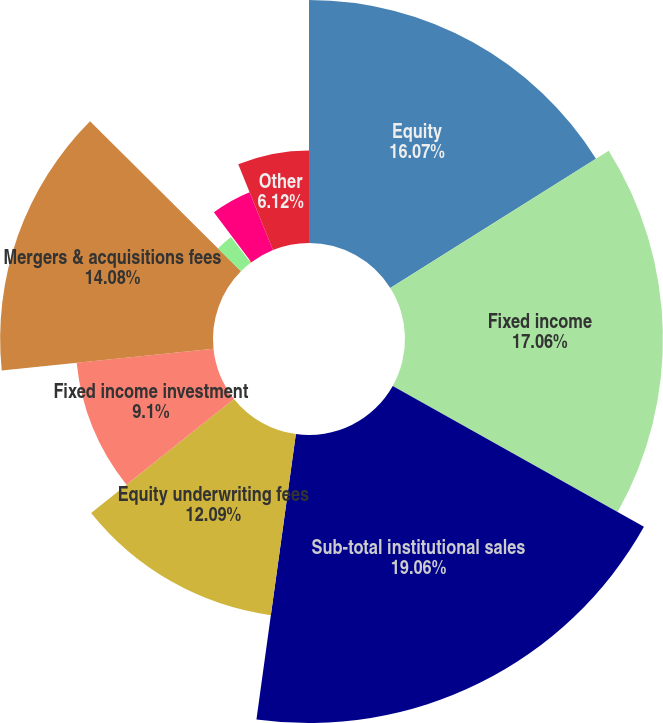Convert chart. <chart><loc_0><loc_0><loc_500><loc_500><pie_chart><fcel>Equity<fcel>Fixed income<fcel>Sub-total institutional sales<fcel>Equity underwriting fees<fcel>Fixed income investment<fcel>Mergers & acquisitions fees<fcel>Tax credit funds syndication<fcel>Private placement fees<fcel>Trading profit<fcel>Other<nl><fcel>16.07%<fcel>17.06%<fcel>19.05%<fcel>12.09%<fcel>9.1%<fcel>14.08%<fcel>2.14%<fcel>0.15%<fcel>4.13%<fcel>6.12%<nl></chart> 